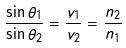Convert formula to latex. <formula><loc_0><loc_0><loc_500><loc_500>\frac { \sin \theta _ { 1 } } { \sin \theta _ { 2 } } = \frac { v _ { 1 } } { v _ { 2 } } = \frac { n _ { 2 } } { n _ { 1 } }</formula> 